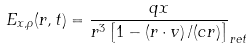<formula> <loc_0><loc_0><loc_500><loc_500>E _ { x , \rho } ( r , t ) = \frac { q x } { r ^ { 3 } \left [ 1 - \left ( r \cdot v \right ) / ( c r ) \right ] } _ { r e t }</formula> 